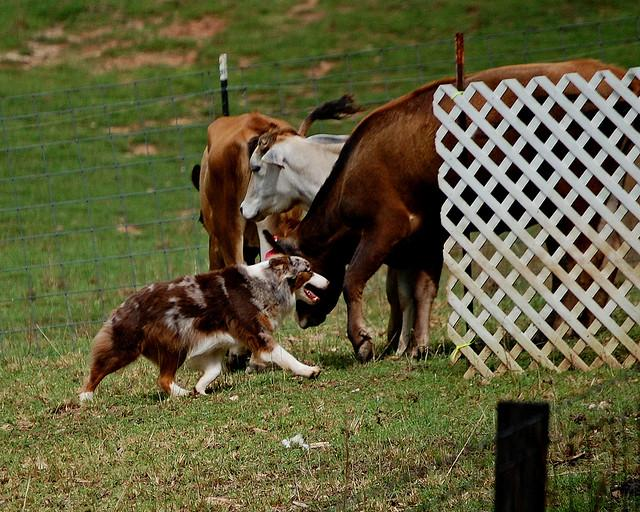What is a male of the larger animals called? Please explain your reasoning. bull. The male is a bull. 